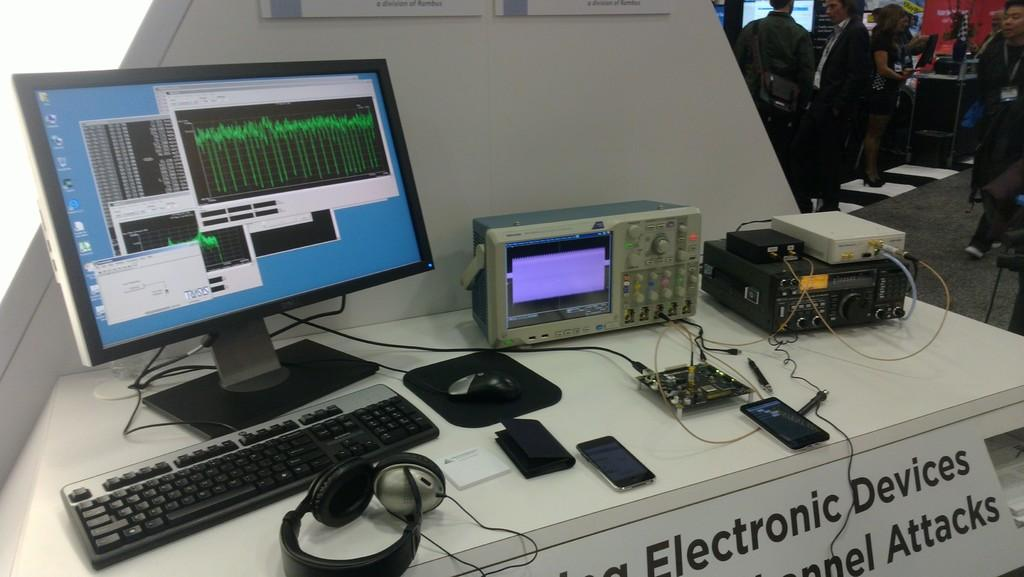Provide a one-sentence caption for the provided image. a computer system is displayed above a sign that reads elecontric devices. 